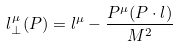<formula> <loc_0><loc_0><loc_500><loc_500>l ^ { \mu } _ { \bot } ( P ) = l ^ { \mu } - \frac { P ^ { \mu } ( P \cdot l ) } { M ^ { 2 } }</formula> 